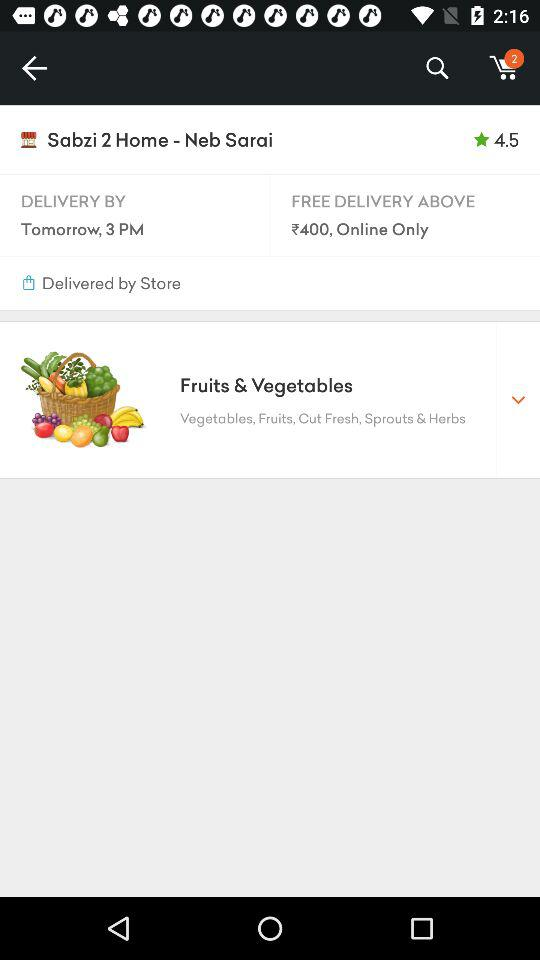How many items in total are in the cart? There are 2 items in total. 